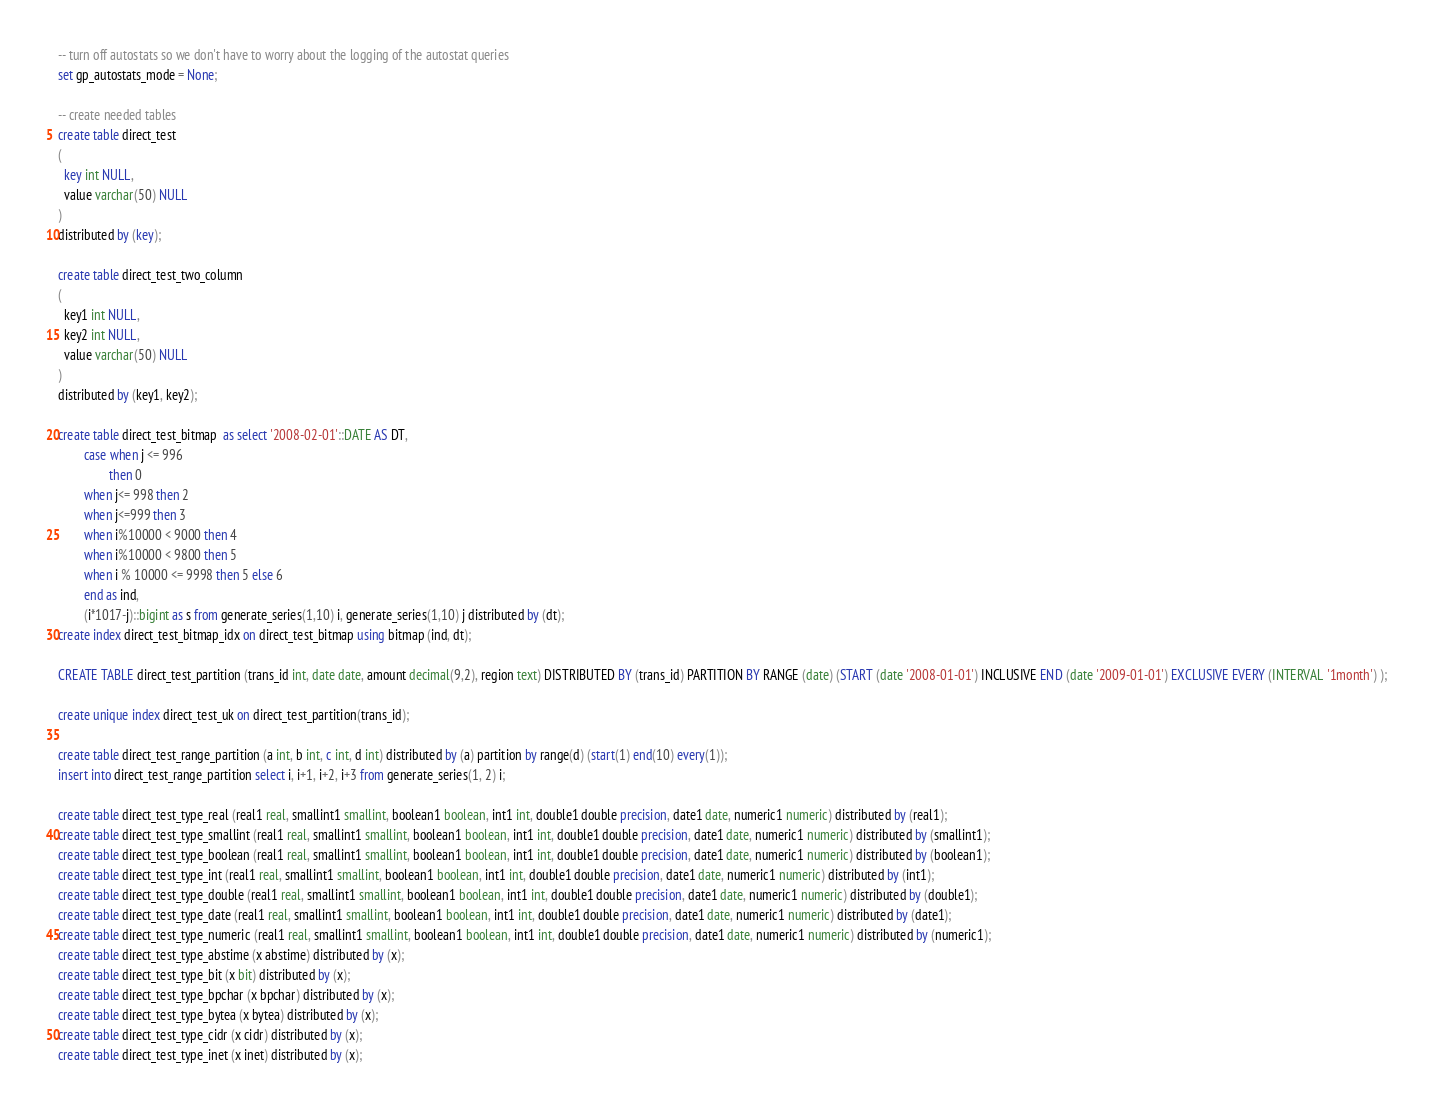Convert code to text. <code><loc_0><loc_0><loc_500><loc_500><_SQL_>-- turn off autostats so we don't have to worry about the logging of the autostat queries
set gp_autostats_mode = None;

-- create needed tables
create table direct_test
(
  key int NULL,
  value varchar(50) NULL
)
distributed by (key); 

create table direct_test_two_column
(
  key1 int NULL,
  key2 int NULL,
  value varchar(50) NULL
)
distributed by (key1, key2);

create table direct_test_bitmap  as select '2008-02-01'::DATE AS DT,
        case when j <= 996
                then 0
        when j<= 998 then 2
        when j<=999 then 3
        when i%10000 < 9000 then 4
        when i%10000 < 9800 then 5
        when i % 10000 <= 9998 then 5 else 6
        end as ind,
        (i*1017-j)::bigint as s from generate_series(1,10) i, generate_series(1,10) j distributed by (dt);
create index direct_test_bitmap_idx on direct_test_bitmap using bitmap (ind, dt);

CREATE TABLE direct_test_partition (trans_id int, date date, amount decimal(9,2), region text) DISTRIBUTED BY (trans_id) PARTITION BY RANGE (date) (START (date '2008-01-01') INCLUSIVE END (date '2009-01-01') EXCLUSIVE EVERY (INTERVAL '1month') );

create unique index direct_test_uk on direct_test_partition(trans_id);

create table direct_test_range_partition (a int, b int, c int, d int) distributed by (a) partition by range(d) (start(1) end(10) every(1));
insert into direct_test_range_partition select i, i+1, i+2, i+3 from generate_series(1, 2) i;

create table direct_test_type_real (real1 real, smallint1 smallint, boolean1 boolean, int1 int, double1 double precision, date1 date, numeric1 numeric) distributed by (real1);
create table direct_test_type_smallint (real1 real, smallint1 smallint, boolean1 boolean, int1 int, double1 double precision, date1 date, numeric1 numeric) distributed by (smallint1);
create table direct_test_type_boolean (real1 real, smallint1 smallint, boolean1 boolean, int1 int, double1 double precision, date1 date, numeric1 numeric) distributed by (boolean1);
create table direct_test_type_int (real1 real, smallint1 smallint, boolean1 boolean, int1 int, double1 double precision, date1 date, numeric1 numeric) distributed by (int1);
create table direct_test_type_double (real1 real, smallint1 smallint, boolean1 boolean, int1 int, double1 double precision, date1 date, numeric1 numeric) distributed by (double1);
create table direct_test_type_date (real1 real, smallint1 smallint, boolean1 boolean, int1 int, double1 double precision, date1 date, numeric1 numeric) distributed by (date1);
create table direct_test_type_numeric (real1 real, smallint1 smallint, boolean1 boolean, int1 int, double1 double precision, date1 date, numeric1 numeric) distributed by (numeric1);
create table direct_test_type_abstime (x abstime) distributed by (x);
create table direct_test_type_bit (x bit) distributed by (x);
create table direct_test_type_bpchar (x bpchar) distributed by (x);
create table direct_test_type_bytea (x bytea) distributed by (x);
create table direct_test_type_cidr (x cidr) distributed by (x);
create table direct_test_type_inet (x inet) distributed by (x);</code> 